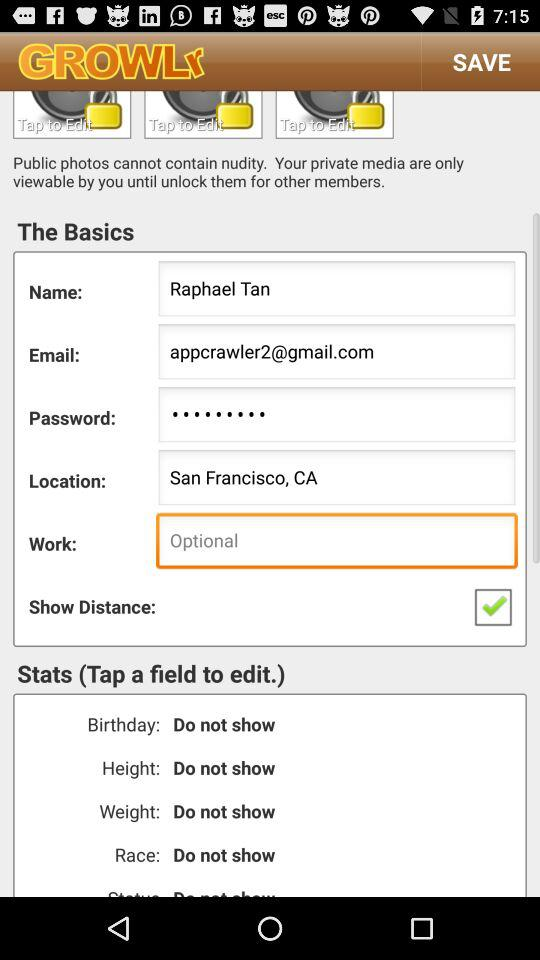How many fields have the label `Do not show`?
Answer the question using a single word or phrase. 4 